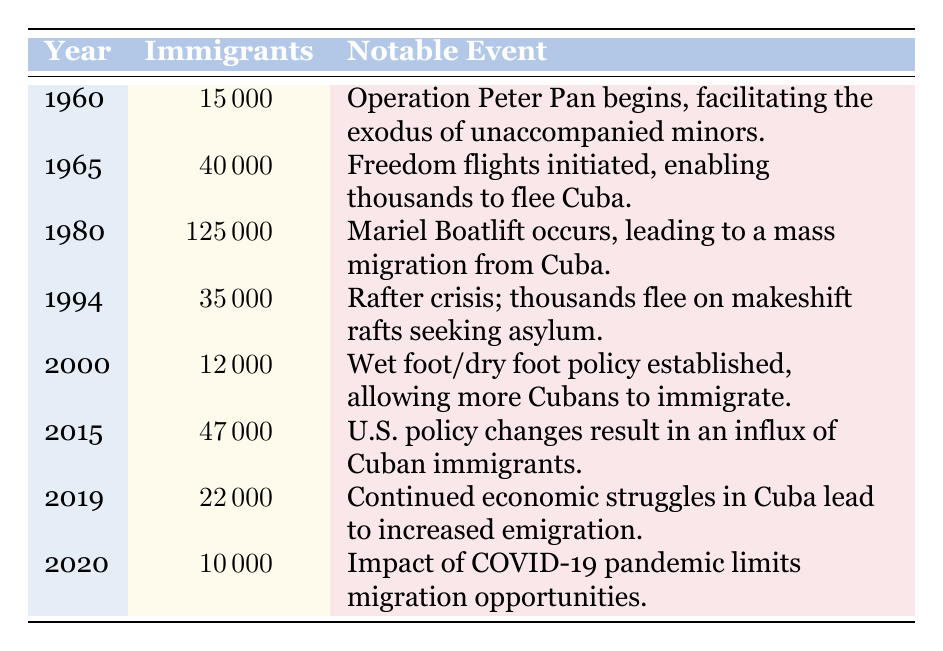What was the year with the highest number of Cuban immigrants? Looking at the table, the highest number of Cuban immigrants occurred in 1980, with 125000 immigrants due to the Mariel Boatlift.
Answer: 1980 How many immigrants moved to the United States in 1965? The table shows that in 1965, there were 40000 Cuban immigrants.
Answer: 40000 What notable event happened in 1994? According to the table, the notable event in 1994 was the Rafter crisis, where thousands fled on makeshift rafts seeking asylum.
Answer: Rafter crisis Was the number of immigrants in 2020 greater than in 2019? In 2020, there were 10000 immigrants whereas in 2019 there were 22000 immigrants. Thus, the statement is false.
Answer: No What is the total number of Cuban immigrants from 2000 to 2020? We add the number of immigrants from 2000 (12000), 2015 (47000), 2019 (22000), and 2020 (10000) together: 12000 + 47000 + 22000 + 10000 = 91000.
Answer: 91000 In which year did the Wet foot/dry foot policy start, and how many immigrants were there that year? The Wet foot/dry foot policy was established in the year 2000, during which there were 12000 immigrants.
Answer: 2000, 12000 Compare the number of immigrants in 1960 and 2015. Was there an increase or decrease? In 1960, there were 15000 immigrants, and in 2015, there were 47000 immigrants. The increase in number is 47000 - 15000 = 32000.
Answer: Increase Which events in the table are associated with mass migration? Looking at the notable events, the Mariel Boatlift in 1980 and the Freedom flights in 1965 are associated with mass migration.
Answer: Mariel Boatlift, Freedom flights How many fewer immigrants were there in 2000 compared to 1980? In 1980, there were 125000 immigrants and in 2000, there were 12000 immigrants. To find the difference, subtract 12000 from 125000: 125000 - 12000 = 113000.
Answer: 113000 